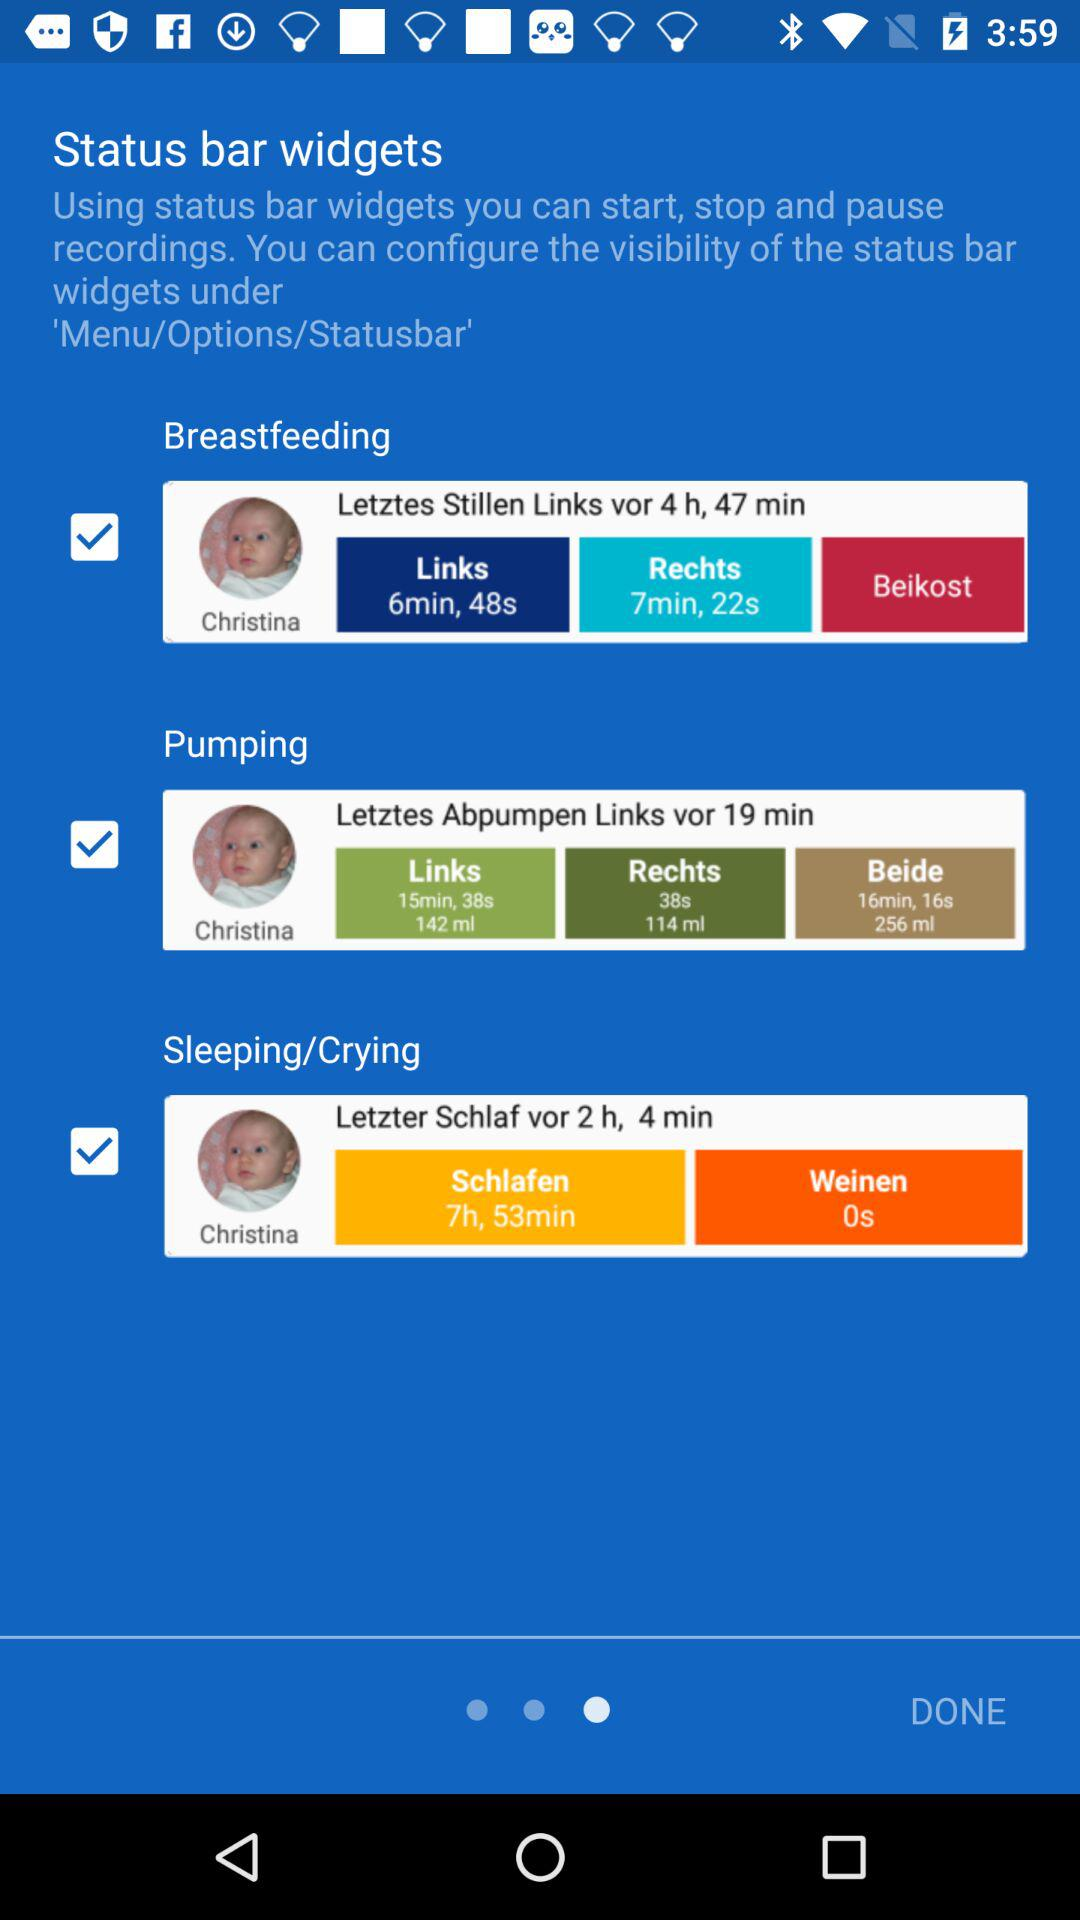Which options are checked? The checked options are "Breastfeeding", "Pumping" and "Sleeping/Crying". 